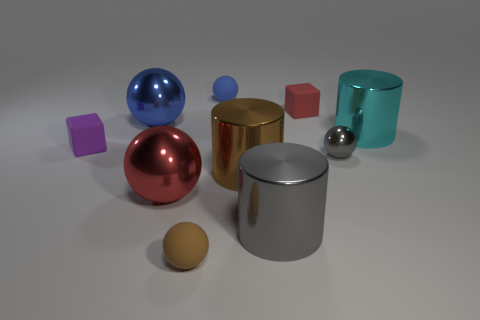There is a metallic thing behind the large metal cylinder on the right side of the large gray object; how big is it?
Make the answer very short. Large. Is the number of gray objects that are to the right of the tiny red thing less than the number of tiny blue spheres?
Your answer should be compact. No. What size is the brown metal thing?
Your response must be concise. Large. What number of matte balls have the same color as the small metal ball?
Provide a short and direct response. 0. There is a shiny cylinder that is behind the gray metallic thing behind the brown cylinder; are there any large shiny balls on the left side of it?
Keep it short and to the point. Yes. The brown thing that is the same size as the cyan metallic cylinder is what shape?
Provide a succinct answer. Cylinder. What number of small objects are either red metal spheres or brown metallic cylinders?
Make the answer very short. 0. What is the color of the tiny thing that is made of the same material as the big blue ball?
Your answer should be very brief. Gray. Do the blue thing on the left side of the tiny brown object and the matte object that is left of the tiny brown object have the same shape?
Ensure brevity in your answer.  No. What number of shiny things are large purple cylinders or big blue balls?
Keep it short and to the point. 1. 